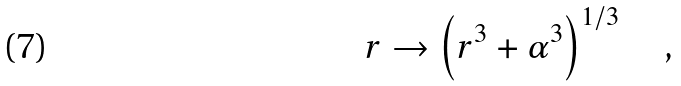<formula> <loc_0><loc_0><loc_500><loc_500>r \rightarrow \left ( r ^ { 3 } + \alpha ^ { 3 } \right ) ^ { 1 / 3 } \quad ,</formula> 